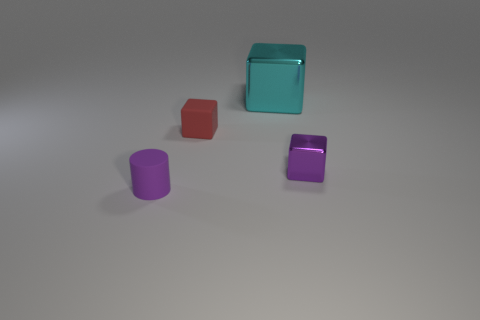Add 4 small purple rubber objects. How many objects exist? 8 Subtract all small metallic cubes. How many cubes are left? 2 Subtract 2 cubes. How many cubes are left? 1 Subtract all red cubes. How many cubes are left? 2 Subtract all blue blocks. Subtract all gray cylinders. How many blocks are left? 3 Subtract all small purple cubes. Subtract all large cyan things. How many objects are left? 2 Add 1 purple matte cylinders. How many purple matte cylinders are left? 2 Add 1 purple shiny things. How many purple shiny things exist? 2 Subtract 0 yellow cubes. How many objects are left? 4 Subtract all cubes. How many objects are left? 1 